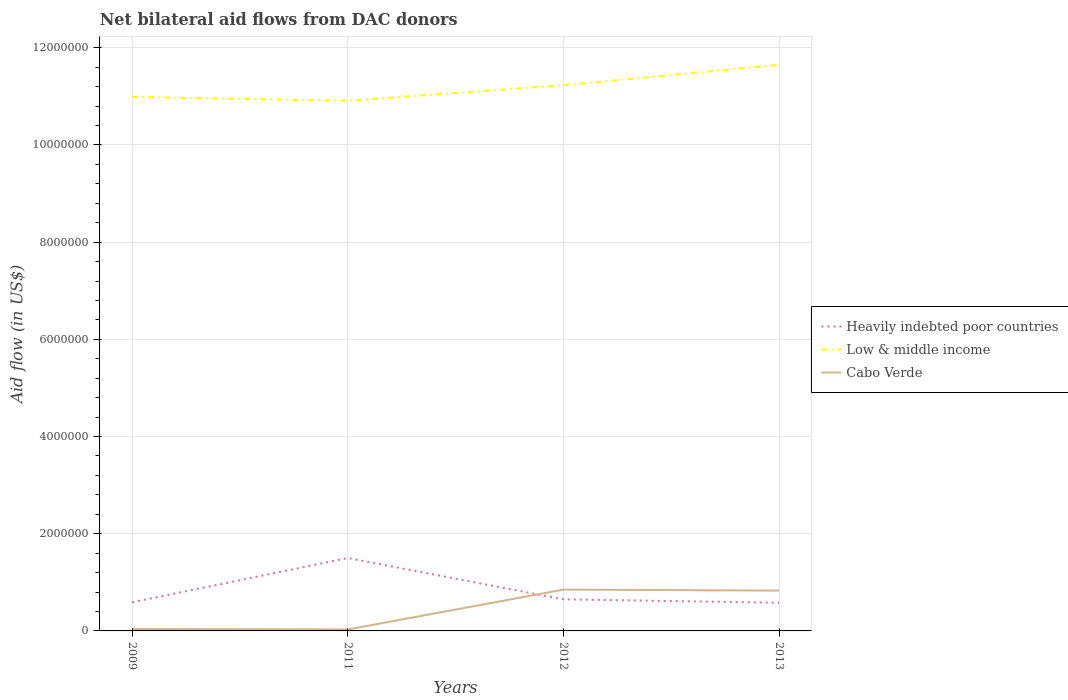How many different coloured lines are there?
Provide a succinct answer. 3. Is the number of lines equal to the number of legend labels?
Your response must be concise. Yes. Across all years, what is the maximum net bilateral aid flow in Low & middle income?
Offer a very short reply. 1.09e+07. What is the total net bilateral aid flow in Cabo Verde in the graph?
Make the answer very short. -8.20e+05. What is the difference between the highest and the second highest net bilateral aid flow in Low & middle income?
Offer a very short reply. 7.40e+05. Is the net bilateral aid flow in Heavily indebted poor countries strictly greater than the net bilateral aid flow in Low & middle income over the years?
Offer a very short reply. Yes. How many lines are there?
Provide a succinct answer. 3. How many years are there in the graph?
Your answer should be very brief. 4. Are the values on the major ticks of Y-axis written in scientific E-notation?
Offer a very short reply. No. Does the graph contain grids?
Your answer should be compact. Yes. How many legend labels are there?
Your response must be concise. 3. What is the title of the graph?
Your response must be concise. Net bilateral aid flows from DAC donors. What is the label or title of the Y-axis?
Your answer should be very brief. Aid flow (in US$). What is the Aid flow (in US$) of Heavily indebted poor countries in 2009?
Keep it short and to the point. 5.90e+05. What is the Aid flow (in US$) of Low & middle income in 2009?
Provide a short and direct response. 1.10e+07. What is the Aid flow (in US$) in Cabo Verde in 2009?
Provide a succinct answer. 4.00e+04. What is the Aid flow (in US$) in Heavily indebted poor countries in 2011?
Offer a terse response. 1.50e+06. What is the Aid flow (in US$) in Low & middle income in 2011?
Give a very brief answer. 1.09e+07. What is the Aid flow (in US$) in Cabo Verde in 2011?
Your answer should be compact. 3.00e+04. What is the Aid flow (in US$) of Heavily indebted poor countries in 2012?
Make the answer very short. 6.50e+05. What is the Aid flow (in US$) of Low & middle income in 2012?
Your answer should be very brief. 1.12e+07. What is the Aid flow (in US$) in Cabo Verde in 2012?
Make the answer very short. 8.50e+05. What is the Aid flow (in US$) in Heavily indebted poor countries in 2013?
Offer a terse response. 5.80e+05. What is the Aid flow (in US$) in Low & middle income in 2013?
Offer a terse response. 1.16e+07. What is the Aid flow (in US$) of Cabo Verde in 2013?
Offer a terse response. 8.30e+05. Across all years, what is the maximum Aid flow (in US$) in Heavily indebted poor countries?
Make the answer very short. 1.50e+06. Across all years, what is the maximum Aid flow (in US$) in Low & middle income?
Your answer should be compact. 1.16e+07. Across all years, what is the maximum Aid flow (in US$) of Cabo Verde?
Your answer should be compact. 8.50e+05. Across all years, what is the minimum Aid flow (in US$) of Heavily indebted poor countries?
Make the answer very short. 5.80e+05. Across all years, what is the minimum Aid flow (in US$) in Low & middle income?
Give a very brief answer. 1.09e+07. What is the total Aid flow (in US$) of Heavily indebted poor countries in the graph?
Make the answer very short. 3.32e+06. What is the total Aid flow (in US$) in Low & middle income in the graph?
Give a very brief answer. 4.48e+07. What is the total Aid flow (in US$) of Cabo Verde in the graph?
Keep it short and to the point. 1.75e+06. What is the difference between the Aid flow (in US$) in Heavily indebted poor countries in 2009 and that in 2011?
Give a very brief answer. -9.10e+05. What is the difference between the Aid flow (in US$) in Cabo Verde in 2009 and that in 2012?
Your answer should be very brief. -8.10e+05. What is the difference between the Aid flow (in US$) in Heavily indebted poor countries in 2009 and that in 2013?
Make the answer very short. 10000. What is the difference between the Aid flow (in US$) of Low & middle income in 2009 and that in 2013?
Provide a succinct answer. -6.60e+05. What is the difference between the Aid flow (in US$) of Cabo Verde in 2009 and that in 2013?
Your response must be concise. -7.90e+05. What is the difference between the Aid flow (in US$) in Heavily indebted poor countries in 2011 and that in 2012?
Offer a terse response. 8.50e+05. What is the difference between the Aid flow (in US$) in Low & middle income in 2011 and that in 2012?
Offer a very short reply. -3.20e+05. What is the difference between the Aid flow (in US$) of Cabo Verde in 2011 and that in 2012?
Offer a very short reply. -8.20e+05. What is the difference between the Aid flow (in US$) of Heavily indebted poor countries in 2011 and that in 2013?
Provide a succinct answer. 9.20e+05. What is the difference between the Aid flow (in US$) of Low & middle income in 2011 and that in 2013?
Keep it short and to the point. -7.40e+05. What is the difference between the Aid flow (in US$) of Cabo Verde in 2011 and that in 2013?
Your answer should be compact. -8.00e+05. What is the difference between the Aid flow (in US$) in Low & middle income in 2012 and that in 2013?
Your answer should be compact. -4.20e+05. What is the difference between the Aid flow (in US$) of Heavily indebted poor countries in 2009 and the Aid flow (in US$) of Low & middle income in 2011?
Give a very brief answer. -1.03e+07. What is the difference between the Aid flow (in US$) of Heavily indebted poor countries in 2009 and the Aid flow (in US$) of Cabo Verde in 2011?
Keep it short and to the point. 5.60e+05. What is the difference between the Aid flow (in US$) of Low & middle income in 2009 and the Aid flow (in US$) of Cabo Verde in 2011?
Keep it short and to the point. 1.10e+07. What is the difference between the Aid flow (in US$) of Heavily indebted poor countries in 2009 and the Aid flow (in US$) of Low & middle income in 2012?
Your answer should be compact. -1.06e+07. What is the difference between the Aid flow (in US$) of Low & middle income in 2009 and the Aid flow (in US$) of Cabo Verde in 2012?
Keep it short and to the point. 1.01e+07. What is the difference between the Aid flow (in US$) of Heavily indebted poor countries in 2009 and the Aid flow (in US$) of Low & middle income in 2013?
Make the answer very short. -1.11e+07. What is the difference between the Aid flow (in US$) of Low & middle income in 2009 and the Aid flow (in US$) of Cabo Verde in 2013?
Keep it short and to the point. 1.02e+07. What is the difference between the Aid flow (in US$) in Heavily indebted poor countries in 2011 and the Aid flow (in US$) in Low & middle income in 2012?
Give a very brief answer. -9.73e+06. What is the difference between the Aid flow (in US$) in Heavily indebted poor countries in 2011 and the Aid flow (in US$) in Cabo Verde in 2012?
Your answer should be very brief. 6.50e+05. What is the difference between the Aid flow (in US$) of Low & middle income in 2011 and the Aid flow (in US$) of Cabo Verde in 2012?
Ensure brevity in your answer.  1.01e+07. What is the difference between the Aid flow (in US$) in Heavily indebted poor countries in 2011 and the Aid flow (in US$) in Low & middle income in 2013?
Give a very brief answer. -1.02e+07. What is the difference between the Aid flow (in US$) in Heavily indebted poor countries in 2011 and the Aid flow (in US$) in Cabo Verde in 2013?
Ensure brevity in your answer.  6.70e+05. What is the difference between the Aid flow (in US$) of Low & middle income in 2011 and the Aid flow (in US$) of Cabo Verde in 2013?
Your response must be concise. 1.01e+07. What is the difference between the Aid flow (in US$) in Heavily indebted poor countries in 2012 and the Aid flow (in US$) in Low & middle income in 2013?
Your response must be concise. -1.10e+07. What is the difference between the Aid flow (in US$) in Heavily indebted poor countries in 2012 and the Aid flow (in US$) in Cabo Verde in 2013?
Your answer should be very brief. -1.80e+05. What is the difference between the Aid flow (in US$) in Low & middle income in 2012 and the Aid flow (in US$) in Cabo Verde in 2013?
Your answer should be very brief. 1.04e+07. What is the average Aid flow (in US$) of Heavily indebted poor countries per year?
Provide a short and direct response. 8.30e+05. What is the average Aid flow (in US$) in Low & middle income per year?
Offer a terse response. 1.12e+07. What is the average Aid flow (in US$) of Cabo Verde per year?
Give a very brief answer. 4.38e+05. In the year 2009, what is the difference between the Aid flow (in US$) of Heavily indebted poor countries and Aid flow (in US$) of Low & middle income?
Make the answer very short. -1.04e+07. In the year 2009, what is the difference between the Aid flow (in US$) in Heavily indebted poor countries and Aid flow (in US$) in Cabo Verde?
Offer a terse response. 5.50e+05. In the year 2009, what is the difference between the Aid flow (in US$) in Low & middle income and Aid flow (in US$) in Cabo Verde?
Keep it short and to the point. 1.10e+07. In the year 2011, what is the difference between the Aid flow (in US$) in Heavily indebted poor countries and Aid flow (in US$) in Low & middle income?
Give a very brief answer. -9.41e+06. In the year 2011, what is the difference between the Aid flow (in US$) of Heavily indebted poor countries and Aid flow (in US$) of Cabo Verde?
Make the answer very short. 1.47e+06. In the year 2011, what is the difference between the Aid flow (in US$) in Low & middle income and Aid flow (in US$) in Cabo Verde?
Ensure brevity in your answer.  1.09e+07. In the year 2012, what is the difference between the Aid flow (in US$) of Heavily indebted poor countries and Aid flow (in US$) of Low & middle income?
Make the answer very short. -1.06e+07. In the year 2012, what is the difference between the Aid flow (in US$) of Low & middle income and Aid flow (in US$) of Cabo Verde?
Offer a very short reply. 1.04e+07. In the year 2013, what is the difference between the Aid flow (in US$) of Heavily indebted poor countries and Aid flow (in US$) of Low & middle income?
Provide a succinct answer. -1.11e+07. In the year 2013, what is the difference between the Aid flow (in US$) in Heavily indebted poor countries and Aid flow (in US$) in Cabo Verde?
Keep it short and to the point. -2.50e+05. In the year 2013, what is the difference between the Aid flow (in US$) in Low & middle income and Aid flow (in US$) in Cabo Verde?
Make the answer very short. 1.08e+07. What is the ratio of the Aid flow (in US$) of Heavily indebted poor countries in 2009 to that in 2011?
Provide a short and direct response. 0.39. What is the ratio of the Aid flow (in US$) in Low & middle income in 2009 to that in 2011?
Make the answer very short. 1.01. What is the ratio of the Aid flow (in US$) in Cabo Verde in 2009 to that in 2011?
Offer a very short reply. 1.33. What is the ratio of the Aid flow (in US$) in Heavily indebted poor countries in 2009 to that in 2012?
Offer a very short reply. 0.91. What is the ratio of the Aid flow (in US$) of Low & middle income in 2009 to that in 2012?
Make the answer very short. 0.98. What is the ratio of the Aid flow (in US$) of Cabo Verde in 2009 to that in 2012?
Make the answer very short. 0.05. What is the ratio of the Aid flow (in US$) of Heavily indebted poor countries in 2009 to that in 2013?
Provide a short and direct response. 1.02. What is the ratio of the Aid flow (in US$) in Low & middle income in 2009 to that in 2013?
Your answer should be very brief. 0.94. What is the ratio of the Aid flow (in US$) of Cabo Verde in 2009 to that in 2013?
Ensure brevity in your answer.  0.05. What is the ratio of the Aid flow (in US$) in Heavily indebted poor countries in 2011 to that in 2012?
Offer a very short reply. 2.31. What is the ratio of the Aid flow (in US$) of Low & middle income in 2011 to that in 2012?
Ensure brevity in your answer.  0.97. What is the ratio of the Aid flow (in US$) in Cabo Verde in 2011 to that in 2012?
Keep it short and to the point. 0.04. What is the ratio of the Aid flow (in US$) in Heavily indebted poor countries in 2011 to that in 2013?
Offer a very short reply. 2.59. What is the ratio of the Aid flow (in US$) in Low & middle income in 2011 to that in 2013?
Your answer should be very brief. 0.94. What is the ratio of the Aid flow (in US$) in Cabo Verde in 2011 to that in 2013?
Keep it short and to the point. 0.04. What is the ratio of the Aid flow (in US$) of Heavily indebted poor countries in 2012 to that in 2013?
Provide a succinct answer. 1.12. What is the ratio of the Aid flow (in US$) of Low & middle income in 2012 to that in 2013?
Keep it short and to the point. 0.96. What is the ratio of the Aid flow (in US$) of Cabo Verde in 2012 to that in 2013?
Provide a short and direct response. 1.02. What is the difference between the highest and the second highest Aid flow (in US$) in Heavily indebted poor countries?
Keep it short and to the point. 8.50e+05. What is the difference between the highest and the second highest Aid flow (in US$) in Low & middle income?
Provide a succinct answer. 4.20e+05. What is the difference between the highest and the second highest Aid flow (in US$) of Cabo Verde?
Your answer should be compact. 2.00e+04. What is the difference between the highest and the lowest Aid flow (in US$) in Heavily indebted poor countries?
Keep it short and to the point. 9.20e+05. What is the difference between the highest and the lowest Aid flow (in US$) in Low & middle income?
Offer a very short reply. 7.40e+05. What is the difference between the highest and the lowest Aid flow (in US$) of Cabo Verde?
Your answer should be compact. 8.20e+05. 